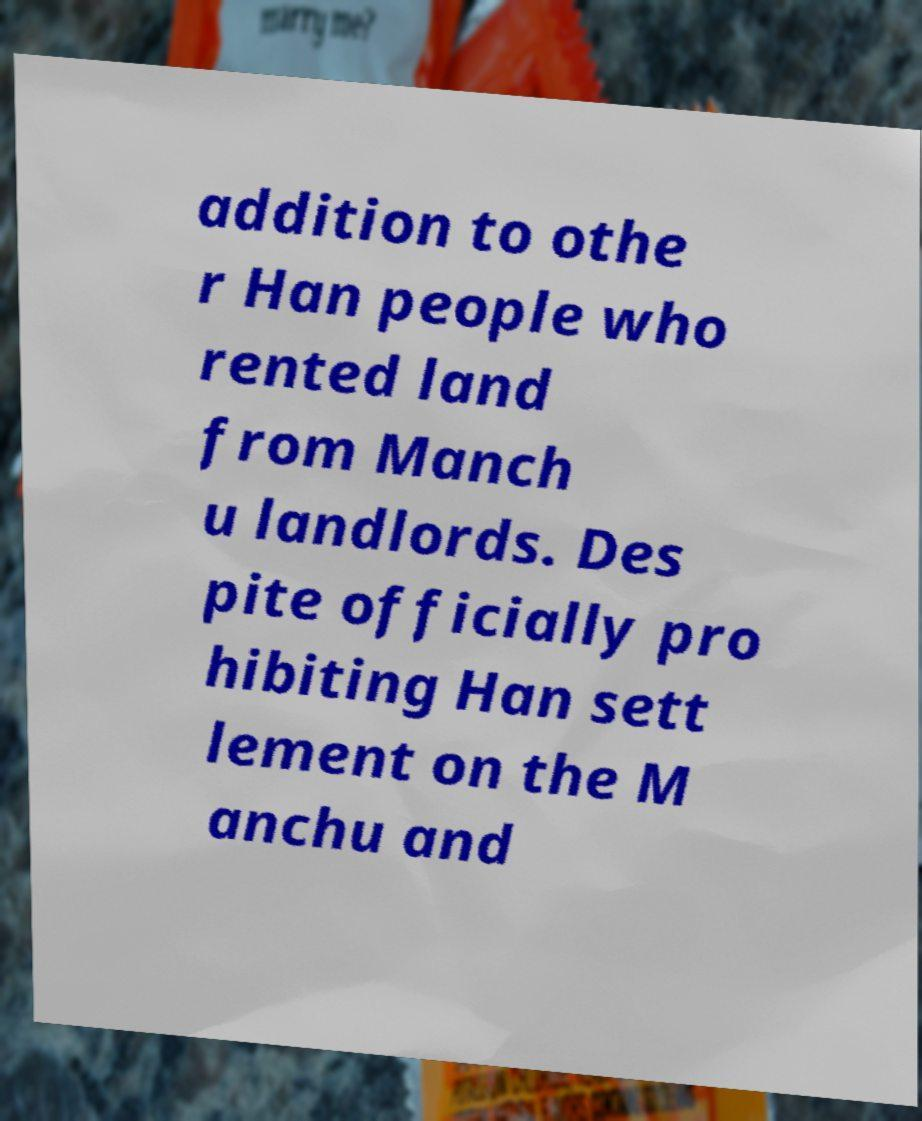I need the written content from this picture converted into text. Can you do that? addition to othe r Han people who rented land from Manch u landlords. Des pite officially pro hibiting Han sett lement on the M anchu and 